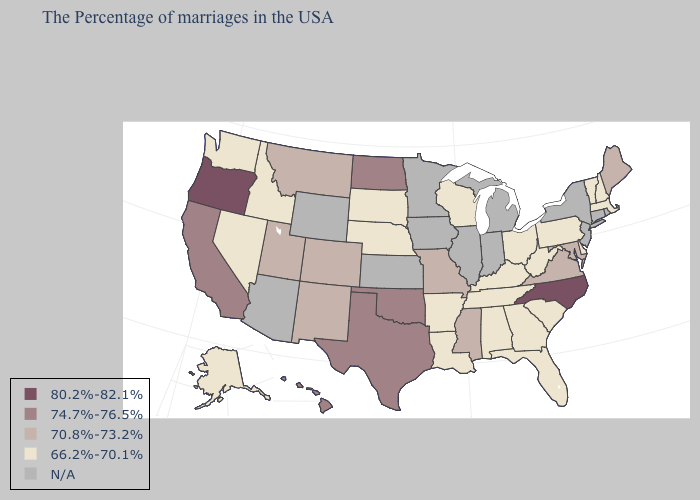What is the highest value in the South ?
Concise answer only. 80.2%-82.1%. Name the states that have a value in the range 70.8%-73.2%?
Be succinct. Maine, Maryland, Virginia, Mississippi, Missouri, Colorado, New Mexico, Utah, Montana. What is the value of Colorado?
Concise answer only. 70.8%-73.2%. What is the lowest value in the West?
Concise answer only. 66.2%-70.1%. What is the lowest value in states that border Washington?
Quick response, please. 66.2%-70.1%. Which states have the lowest value in the Northeast?
Give a very brief answer. Massachusetts, New Hampshire, Vermont, Pennsylvania. Is the legend a continuous bar?
Give a very brief answer. No. What is the lowest value in the USA?
Give a very brief answer. 66.2%-70.1%. Does the map have missing data?
Write a very short answer. Yes. Name the states that have a value in the range 74.7%-76.5%?
Concise answer only. Oklahoma, Texas, North Dakota, California, Hawaii. Name the states that have a value in the range 80.2%-82.1%?
Answer briefly. North Carolina, Oregon. What is the lowest value in the USA?
Short answer required. 66.2%-70.1%. Which states have the lowest value in the West?
Quick response, please. Idaho, Nevada, Washington, Alaska. Does the first symbol in the legend represent the smallest category?
Concise answer only. No. Which states hav the highest value in the West?
Be succinct. Oregon. 